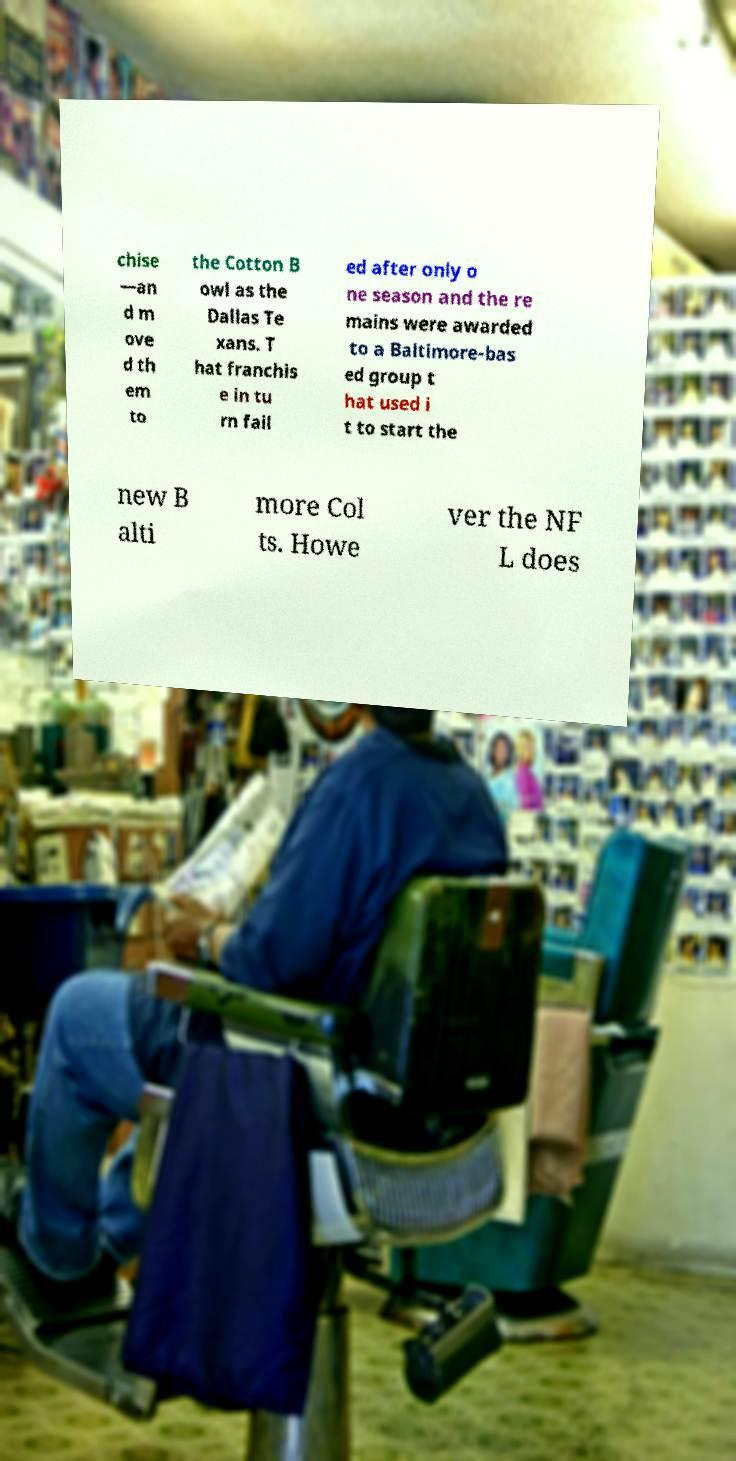Can you accurately transcribe the text from the provided image for me? chise —an d m ove d th em to the Cotton B owl as the Dallas Te xans. T hat franchis e in tu rn fail ed after only o ne season and the re mains were awarded to a Baltimore-bas ed group t hat used i t to start the new B alti more Col ts. Howe ver the NF L does 